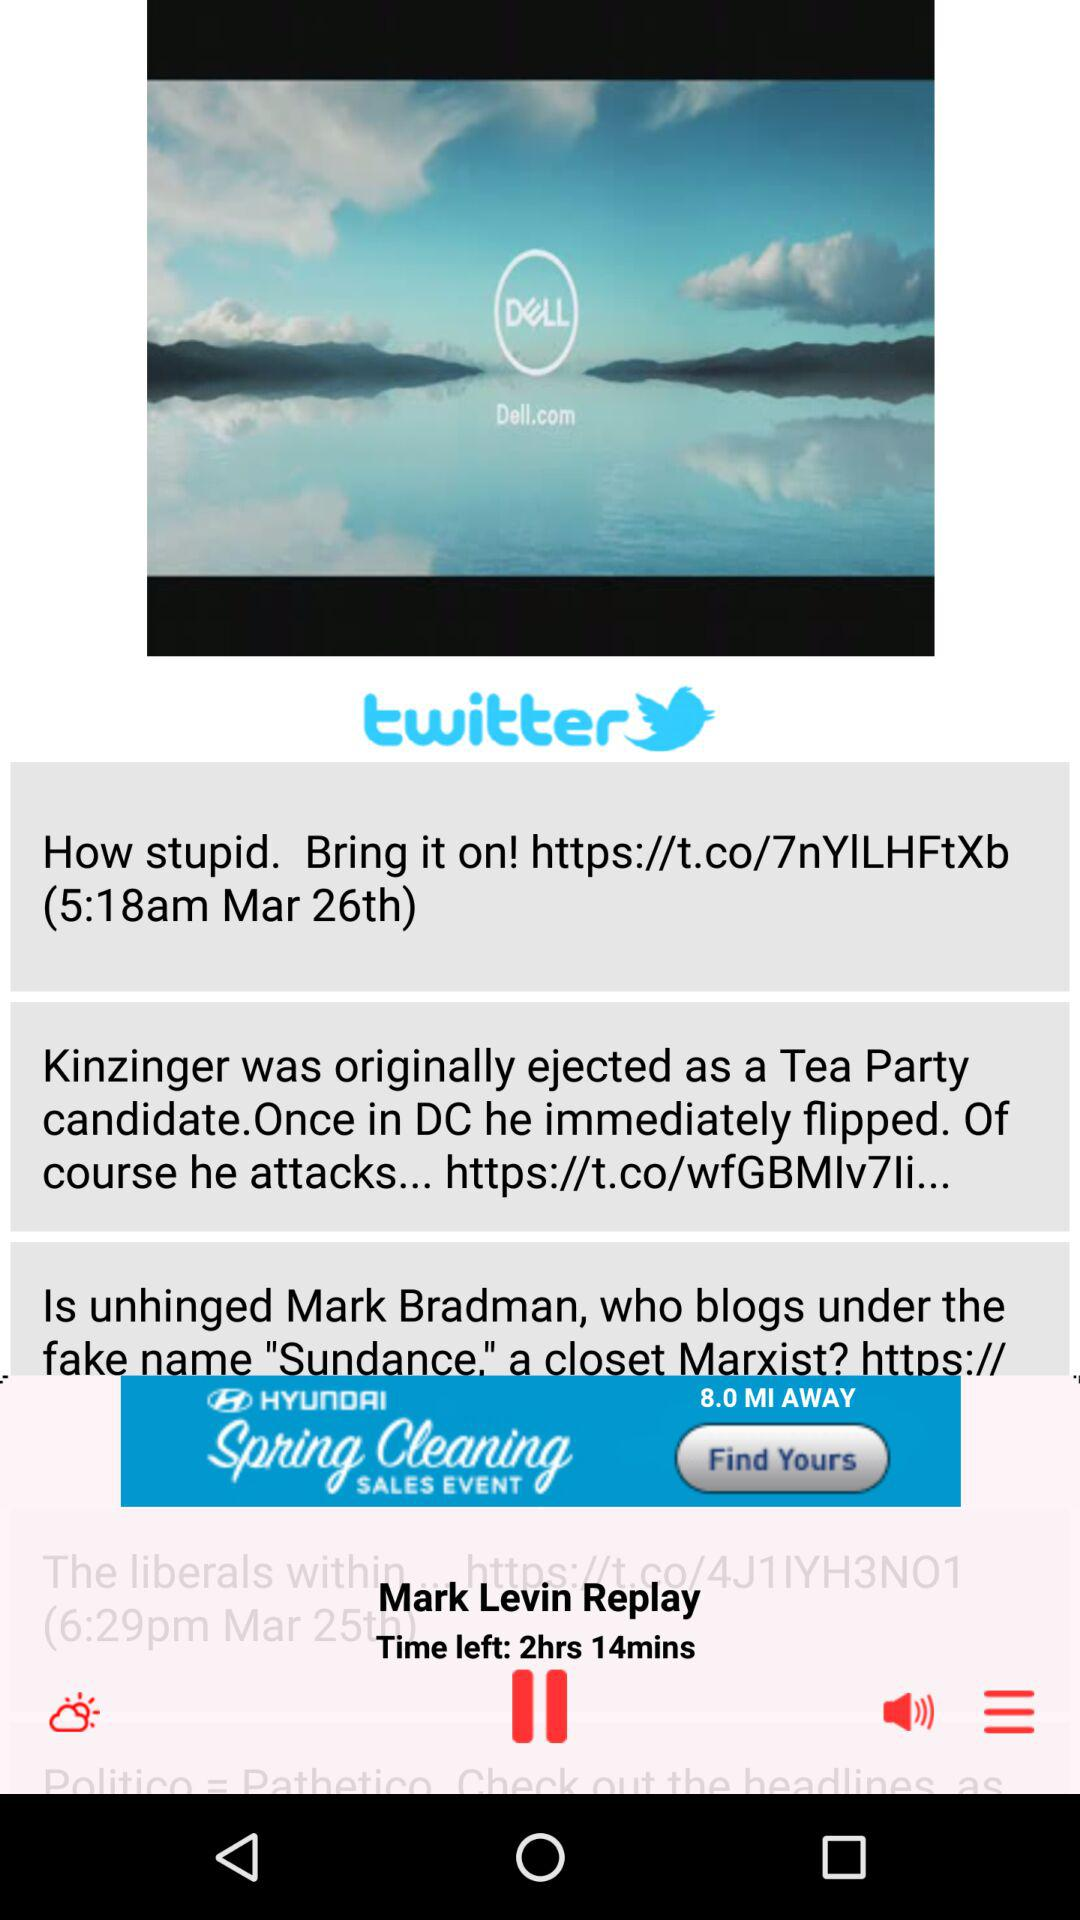Which audio is currently playing? The currently playing audio is "Mark Levin Replay". 